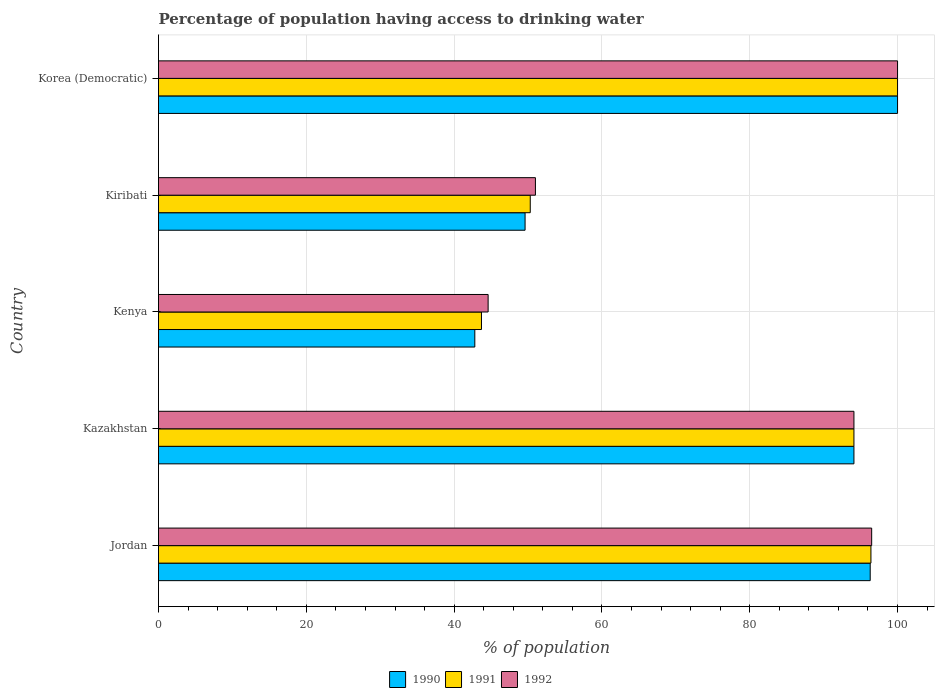How many different coloured bars are there?
Ensure brevity in your answer.  3. How many bars are there on the 3rd tick from the top?
Keep it short and to the point. 3. What is the label of the 3rd group of bars from the top?
Ensure brevity in your answer.  Kenya. What is the percentage of population having access to drinking water in 1991 in Kiribati?
Your answer should be very brief. 50.3. Across all countries, what is the maximum percentage of population having access to drinking water in 1991?
Give a very brief answer. 100. Across all countries, what is the minimum percentage of population having access to drinking water in 1992?
Your answer should be very brief. 44.6. In which country was the percentage of population having access to drinking water in 1990 maximum?
Give a very brief answer. Korea (Democratic). In which country was the percentage of population having access to drinking water in 1990 minimum?
Provide a succinct answer. Kenya. What is the total percentage of population having access to drinking water in 1991 in the graph?
Make the answer very short. 384.5. What is the difference between the percentage of population having access to drinking water in 1991 in Kazakhstan and that in Kiribati?
Provide a succinct answer. 43.8. What is the difference between the percentage of population having access to drinking water in 1991 in Jordan and the percentage of population having access to drinking water in 1990 in Kenya?
Your response must be concise. 53.6. What is the average percentage of population having access to drinking water in 1991 per country?
Your answer should be very brief. 76.9. What is the difference between the percentage of population having access to drinking water in 1991 and percentage of population having access to drinking water in 1992 in Kiribati?
Your answer should be compact. -0.7. In how many countries, is the percentage of population having access to drinking water in 1991 greater than 4 %?
Make the answer very short. 5. What is the ratio of the percentage of population having access to drinking water in 1992 in Jordan to that in Kazakhstan?
Make the answer very short. 1.03. Is the percentage of population having access to drinking water in 1991 in Jordan less than that in Kenya?
Offer a terse response. No. Is the difference between the percentage of population having access to drinking water in 1991 in Jordan and Kenya greater than the difference between the percentage of population having access to drinking water in 1992 in Jordan and Kenya?
Make the answer very short. Yes. What is the difference between the highest and the second highest percentage of population having access to drinking water in 1992?
Make the answer very short. 3.5. What is the difference between the highest and the lowest percentage of population having access to drinking water in 1992?
Ensure brevity in your answer.  55.4. What does the 2nd bar from the top in Jordan represents?
Your answer should be very brief. 1991. What does the 1st bar from the bottom in Kiribati represents?
Give a very brief answer. 1990. How many bars are there?
Make the answer very short. 15. Are all the bars in the graph horizontal?
Your answer should be compact. Yes. Are the values on the major ticks of X-axis written in scientific E-notation?
Offer a terse response. No. Does the graph contain any zero values?
Offer a very short reply. No. How many legend labels are there?
Offer a terse response. 3. What is the title of the graph?
Your answer should be very brief. Percentage of population having access to drinking water. Does "1972" appear as one of the legend labels in the graph?
Your answer should be very brief. No. What is the label or title of the X-axis?
Provide a succinct answer. % of population. What is the label or title of the Y-axis?
Make the answer very short. Country. What is the % of population in 1990 in Jordan?
Keep it short and to the point. 96.3. What is the % of population of 1991 in Jordan?
Give a very brief answer. 96.4. What is the % of population in 1992 in Jordan?
Keep it short and to the point. 96.5. What is the % of population in 1990 in Kazakhstan?
Keep it short and to the point. 94.1. What is the % of population of 1991 in Kazakhstan?
Offer a terse response. 94.1. What is the % of population of 1992 in Kazakhstan?
Your response must be concise. 94.1. What is the % of population of 1990 in Kenya?
Your response must be concise. 42.8. What is the % of population in 1991 in Kenya?
Provide a short and direct response. 43.7. What is the % of population of 1992 in Kenya?
Keep it short and to the point. 44.6. What is the % of population in 1990 in Kiribati?
Provide a short and direct response. 49.6. What is the % of population of 1991 in Kiribati?
Offer a terse response. 50.3. What is the % of population in 1992 in Kiribati?
Make the answer very short. 51. What is the % of population of 1990 in Korea (Democratic)?
Make the answer very short. 100. Across all countries, what is the maximum % of population of 1990?
Ensure brevity in your answer.  100. Across all countries, what is the maximum % of population of 1991?
Provide a succinct answer. 100. Across all countries, what is the maximum % of population of 1992?
Ensure brevity in your answer.  100. Across all countries, what is the minimum % of population of 1990?
Make the answer very short. 42.8. Across all countries, what is the minimum % of population in 1991?
Ensure brevity in your answer.  43.7. Across all countries, what is the minimum % of population of 1992?
Provide a short and direct response. 44.6. What is the total % of population in 1990 in the graph?
Your answer should be compact. 382.8. What is the total % of population in 1991 in the graph?
Your answer should be very brief. 384.5. What is the total % of population in 1992 in the graph?
Your response must be concise. 386.2. What is the difference between the % of population of 1990 in Jordan and that in Kazakhstan?
Offer a very short reply. 2.2. What is the difference between the % of population of 1991 in Jordan and that in Kazakhstan?
Provide a succinct answer. 2.3. What is the difference between the % of population of 1990 in Jordan and that in Kenya?
Your answer should be very brief. 53.5. What is the difference between the % of population of 1991 in Jordan and that in Kenya?
Provide a succinct answer. 52.7. What is the difference between the % of population of 1992 in Jordan and that in Kenya?
Keep it short and to the point. 51.9. What is the difference between the % of population of 1990 in Jordan and that in Kiribati?
Your answer should be very brief. 46.7. What is the difference between the % of population of 1991 in Jordan and that in Kiribati?
Keep it short and to the point. 46.1. What is the difference between the % of population of 1992 in Jordan and that in Kiribati?
Keep it short and to the point. 45.5. What is the difference between the % of population in 1990 in Jordan and that in Korea (Democratic)?
Make the answer very short. -3.7. What is the difference between the % of population of 1992 in Jordan and that in Korea (Democratic)?
Keep it short and to the point. -3.5. What is the difference between the % of population of 1990 in Kazakhstan and that in Kenya?
Provide a succinct answer. 51.3. What is the difference between the % of population of 1991 in Kazakhstan and that in Kenya?
Your answer should be very brief. 50.4. What is the difference between the % of population of 1992 in Kazakhstan and that in Kenya?
Offer a terse response. 49.5. What is the difference between the % of population in 1990 in Kazakhstan and that in Kiribati?
Your answer should be very brief. 44.5. What is the difference between the % of population in 1991 in Kazakhstan and that in Kiribati?
Provide a succinct answer. 43.8. What is the difference between the % of population of 1992 in Kazakhstan and that in Kiribati?
Offer a very short reply. 43.1. What is the difference between the % of population of 1990 in Kazakhstan and that in Korea (Democratic)?
Your answer should be very brief. -5.9. What is the difference between the % of population in 1991 in Kazakhstan and that in Korea (Democratic)?
Keep it short and to the point. -5.9. What is the difference between the % of population of 1991 in Kenya and that in Kiribati?
Your answer should be compact. -6.6. What is the difference between the % of population of 1990 in Kenya and that in Korea (Democratic)?
Make the answer very short. -57.2. What is the difference between the % of population in 1991 in Kenya and that in Korea (Democratic)?
Keep it short and to the point. -56.3. What is the difference between the % of population of 1992 in Kenya and that in Korea (Democratic)?
Offer a very short reply. -55.4. What is the difference between the % of population of 1990 in Kiribati and that in Korea (Democratic)?
Your answer should be compact. -50.4. What is the difference between the % of population in 1991 in Kiribati and that in Korea (Democratic)?
Ensure brevity in your answer.  -49.7. What is the difference between the % of population in 1992 in Kiribati and that in Korea (Democratic)?
Ensure brevity in your answer.  -49. What is the difference between the % of population of 1990 in Jordan and the % of population of 1992 in Kazakhstan?
Provide a short and direct response. 2.2. What is the difference between the % of population in 1991 in Jordan and the % of population in 1992 in Kazakhstan?
Offer a terse response. 2.3. What is the difference between the % of population of 1990 in Jordan and the % of population of 1991 in Kenya?
Make the answer very short. 52.6. What is the difference between the % of population in 1990 in Jordan and the % of population in 1992 in Kenya?
Offer a very short reply. 51.7. What is the difference between the % of population in 1991 in Jordan and the % of population in 1992 in Kenya?
Offer a very short reply. 51.8. What is the difference between the % of population of 1990 in Jordan and the % of population of 1991 in Kiribati?
Your answer should be compact. 46. What is the difference between the % of population in 1990 in Jordan and the % of population in 1992 in Kiribati?
Your answer should be compact. 45.3. What is the difference between the % of population of 1991 in Jordan and the % of population of 1992 in Kiribati?
Provide a short and direct response. 45.4. What is the difference between the % of population in 1990 in Jordan and the % of population in 1992 in Korea (Democratic)?
Keep it short and to the point. -3.7. What is the difference between the % of population of 1991 in Jordan and the % of population of 1992 in Korea (Democratic)?
Keep it short and to the point. -3.6. What is the difference between the % of population in 1990 in Kazakhstan and the % of population in 1991 in Kenya?
Ensure brevity in your answer.  50.4. What is the difference between the % of population of 1990 in Kazakhstan and the % of population of 1992 in Kenya?
Your answer should be compact. 49.5. What is the difference between the % of population of 1991 in Kazakhstan and the % of population of 1992 in Kenya?
Your response must be concise. 49.5. What is the difference between the % of population in 1990 in Kazakhstan and the % of population in 1991 in Kiribati?
Keep it short and to the point. 43.8. What is the difference between the % of population in 1990 in Kazakhstan and the % of population in 1992 in Kiribati?
Offer a terse response. 43.1. What is the difference between the % of population in 1991 in Kazakhstan and the % of population in 1992 in Kiribati?
Your answer should be very brief. 43.1. What is the difference between the % of population of 1990 in Kenya and the % of population of 1992 in Kiribati?
Provide a succinct answer. -8.2. What is the difference between the % of population of 1991 in Kenya and the % of population of 1992 in Kiribati?
Provide a succinct answer. -7.3. What is the difference between the % of population in 1990 in Kenya and the % of population in 1991 in Korea (Democratic)?
Your response must be concise. -57.2. What is the difference between the % of population of 1990 in Kenya and the % of population of 1992 in Korea (Democratic)?
Ensure brevity in your answer.  -57.2. What is the difference between the % of population in 1991 in Kenya and the % of population in 1992 in Korea (Democratic)?
Keep it short and to the point. -56.3. What is the difference between the % of population of 1990 in Kiribati and the % of population of 1991 in Korea (Democratic)?
Offer a terse response. -50.4. What is the difference between the % of population of 1990 in Kiribati and the % of population of 1992 in Korea (Democratic)?
Make the answer very short. -50.4. What is the difference between the % of population in 1991 in Kiribati and the % of population in 1992 in Korea (Democratic)?
Keep it short and to the point. -49.7. What is the average % of population of 1990 per country?
Provide a succinct answer. 76.56. What is the average % of population in 1991 per country?
Offer a very short reply. 76.9. What is the average % of population of 1992 per country?
Your response must be concise. 77.24. What is the difference between the % of population of 1990 and % of population of 1991 in Jordan?
Provide a succinct answer. -0.1. What is the difference between the % of population of 1990 and % of population of 1992 in Jordan?
Your response must be concise. -0.2. What is the difference between the % of population of 1990 and % of population of 1991 in Kazakhstan?
Give a very brief answer. 0. What is the difference between the % of population of 1990 and % of population of 1992 in Kazakhstan?
Your response must be concise. 0. What is the difference between the % of population in 1990 and % of population in 1991 in Kiribati?
Give a very brief answer. -0.7. What is the difference between the % of population of 1990 and % of population of 1992 in Kiribati?
Ensure brevity in your answer.  -1.4. What is the difference between the % of population in 1990 and % of population in 1992 in Korea (Democratic)?
Your response must be concise. 0. What is the ratio of the % of population in 1990 in Jordan to that in Kazakhstan?
Your answer should be compact. 1.02. What is the ratio of the % of population in 1991 in Jordan to that in Kazakhstan?
Your answer should be very brief. 1.02. What is the ratio of the % of population of 1992 in Jordan to that in Kazakhstan?
Keep it short and to the point. 1.03. What is the ratio of the % of population of 1990 in Jordan to that in Kenya?
Offer a terse response. 2.25. What is the ratio of the % of population in 1991 in Jordan to that in Kenya?
Give a very brief answer. 2.21. What is the ratio of the % of population in 1992 in Jordan to that in Kenya?
Your answer should be compact. 2.16. What is the ratio of the % of population in 1990 in Jordan to that in Kiribati?
Offer a terse response. 1.94. What is the ratio of the % of population of 1991 in Jordan to that in Kiribati?
Your answer should be compact. 1.92. What is the ratio of the % of population in 1992 in Jordan to that in Kiribati?
Your answer should be very brief. 1.89. What is the ratio of the % of population in 1990 in Jordan to that in Korea (Democratic)?
Make the answer very short. 0.96. What is the ratio of the % of population of 1990 in Kazakhstan to that in Kenya?
Make the answer very short. 2.2. What is the ratio of the % of population of 1991 in Kazakhstan to that in Kenya?
Your answer should be compact. 2.15. What is the ratio of the % of population in 1992 in Kazakhstan to that in Kenya?
Your answer should be very brief. 2.11. What is the ratio of the % of population of 1990 in Kazakhstan to that in Kiribati?
Your answer should be very brief. 1.9. What is the ratio of the % of population in 1991 in Kazakhstan to that in Kiribati?
Ensure brevity in your answer.  1.87. What is the ratio of the % of population of 1992 in Kazakhstan to that in Kiribati?
Keep it short and to the point. 1.85. What is the ratio of the % of population in 1990 in Kazakhstan to that in Korea (Democratic)?
Provide a succinct answer. 0.94. What is the ratio of the % of population in 1991 in Kazakhstan to that in Korea (Democratic)?
Your response must be concise. 0.94. What is the ratio of the % of population in 1992 in Kazakhstan to that in Korea (Democratic)?
Offer a terse response. 0.94. What is the ratio of the % of population in 1990 in Kenya to that in Kiribati?
Give a very brief answer. 0.86. What is the ratio of the % of population of 1991 in Kenya to that in Kiribati?
Your response must be concise. 0.87. What is the ratio of the % of population of 1992 in Kenya to that in Kiribati?
Your answer should be compact. 0.87. What is the ratio of the % of population in 1990 in Kenya to that in Korea (Democratic)?
Offer a terse response. 0.43. What is the ratio of the % of population of 1991 in Kenya to that in Korea (Democratic)?
Offer a terse response. 0.44. What is the ratio of the % of population in 1992 in Kenya to that in Korea (Democratic)?
Offer a very short reply. 0.45. What is the ratio of the % of population of 1990 in Kiribati to that in Korea (Democratic)?
Give a very brief answer. 0.5. What is the ratio of the % of population in 1991 in Kiribati to that in Korea (Democratic)?
Make the answer very short. 0.5. What is the ratio of the % of population of 1992 in Kiribati to that in Korea (Democratic)?
Ensure brevity in your answer.  0.51. What is the difference between the highest and the second highest % of population in 1990?
Provide a succinct answer. 3.7. What is the difference between the highest and the second highest % of population in 1991?
Give a very brief answer. 3.6. What is the difference between the highest and the lowest % of population in 1990?
Offer a terse response. 57.2. What is the difference between the highest and the lowest % of population of 1991?
Your response must be concise. 56.3. What is the difference between the highest and the lowest % of population of 1992?
Provide a succinct answer. 55.4. 